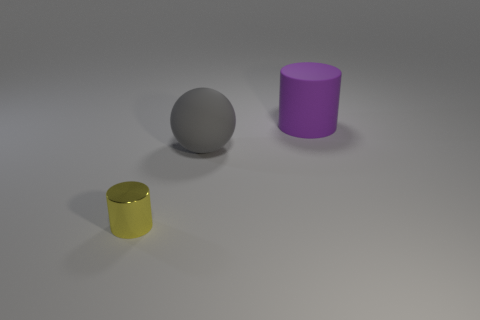Are there any other things that are made of the same material as the small yellow object?
Provide a succinct answer. No. How many tiny objects are gray matte things or yellow things?
Offer a terse response. 1. Is there a thing made of the same material as the sphere?
Your answer should be very brief. Yes. What material is the big object that is left of the matte cylinder?
Make the answer very short. Rubber. There is another matte thing that is the same size as the purple rubber thing; what color is it?
Keep it short and to the point. Gray. What number of other things are the same shape as the yellow metallic object?
Offer a very short reply. 1. There is a cylinder that is on the right side of the tiny metallic thing; how big is it?
Keep it short and to the point. Large. How many purple rubber cylinders are behind the cylinder that is behind the yellow metallic thing?
Ensure brevity in your answer.  0. What number of other objects are there of the same size as the rubber cylinder?
Make the answer very short. 1. Do the large rubber thing that is in front of the purple rubber object and the small thing have the same shape?
Make the answer very short. No. 